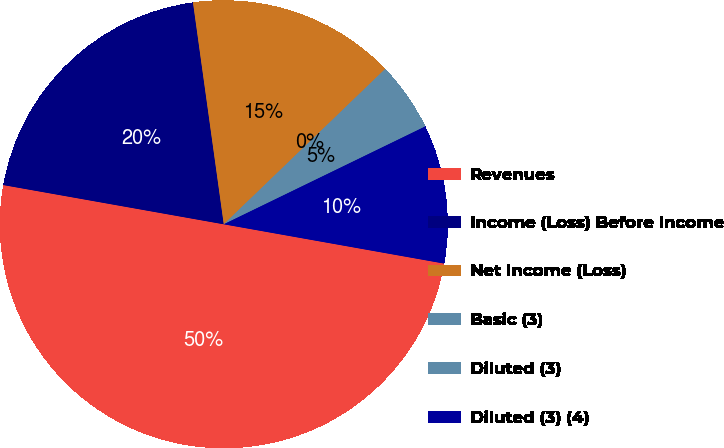Convert chart to OTSL. <chart><loc_0><loc_0><loc_500><loc_500><pie_chart><fcel>Revenues<fcel>Income (Loss) Before Income<fcel>Net Income (Loss)<fcel>Basic (3)<fcel>Diluted (3)<fcel>Diluted (3) (4)<nl><fcel>49.99%<fcel>20.0%<fcel>15.0%<fcel>0.0%<fcel>5.0%<fcel>10.0%<nl></chart> 